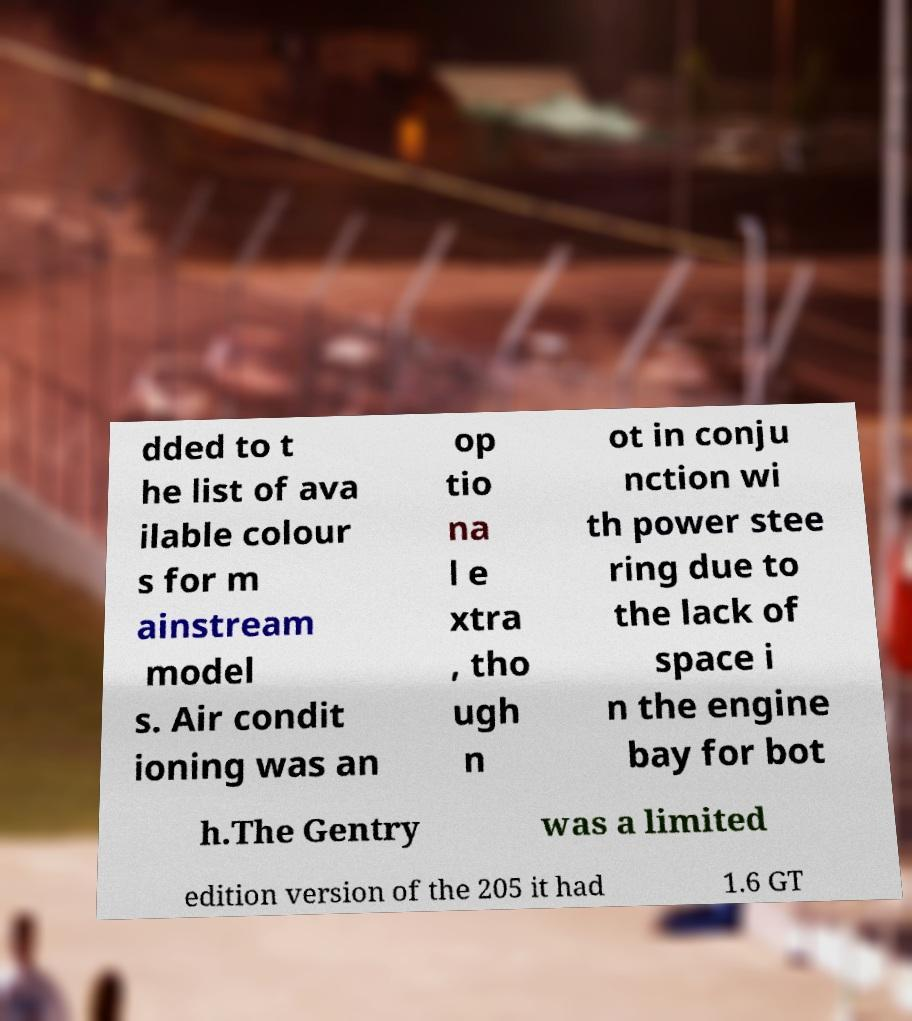There's text embedded in this image that I need extracted. Can you transcribe it verbatim? dded to t he list of ava ilable colour s for m ainstream model s. Air condit ioning was an op tio na l e xtra , tho ugh n ot in conju nction wi th power stee ring due to the lack of space i n the engine bay for bot h.The Gentry was a limited edition version of the 205 it had 1.6 GT 